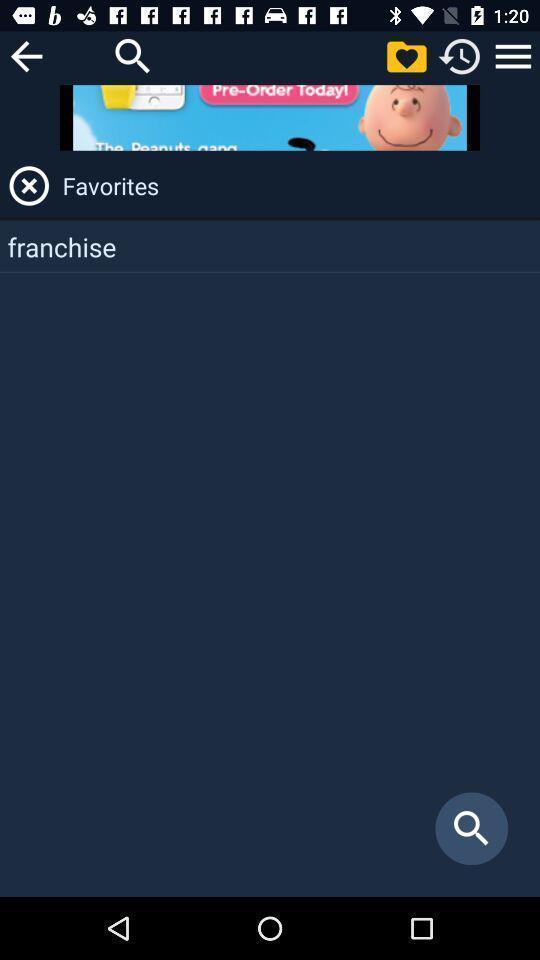Describe this image in words. Page showing about search bar and favorites. 